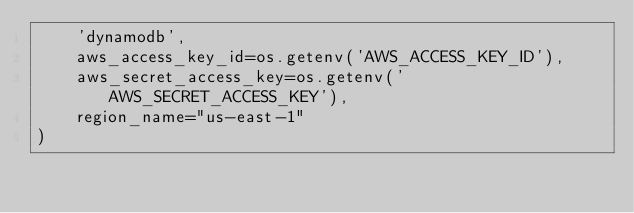<code> <loc_0><loc_0><loc_500><loc_500><_Python_>    'dynamodb',
    aws_access_key_id=os.getenv('AWS_ACCESS_KEY_ID'),
    aws_secret_access_key=os.getenv('AWS_SECRET_ACCESS_KEY'),
    region_name="us-east-1"
)
</code> 